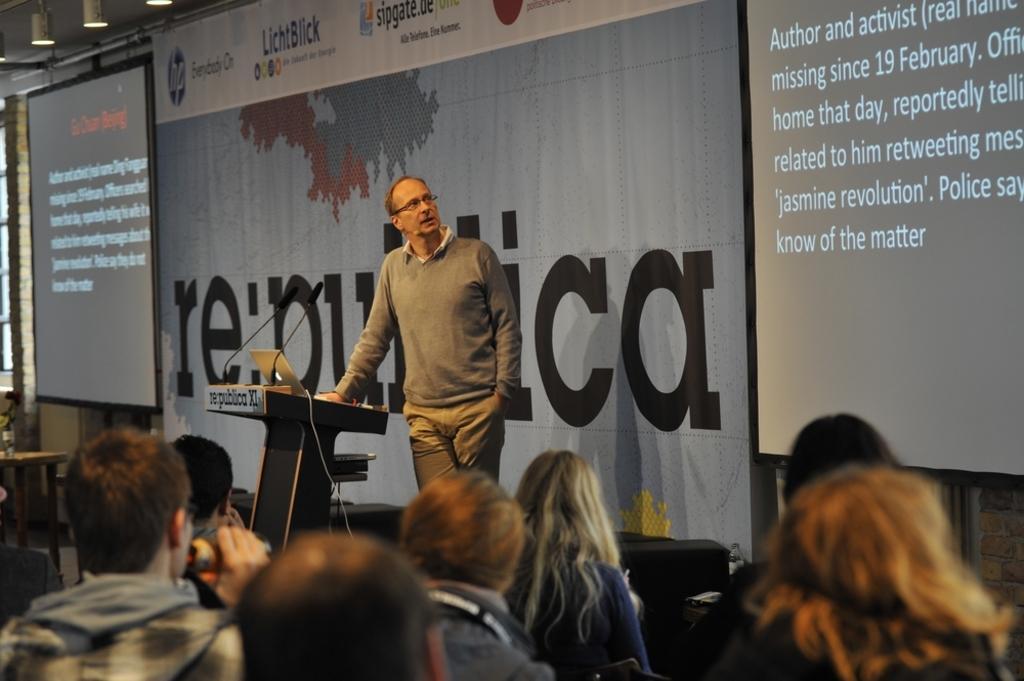How would you summarize this image in a sentence or two? As we can see in the image there are screens, lights, table, mics, laptop and group of people. 